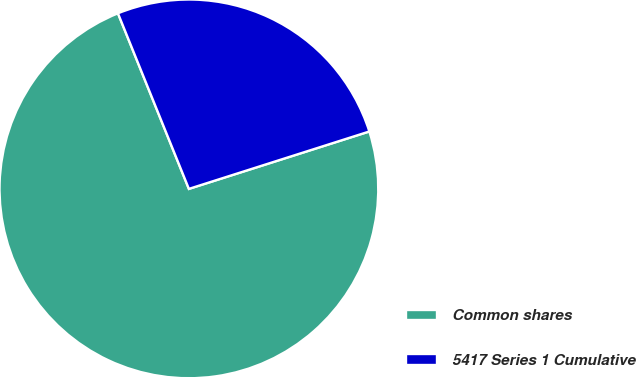<chart> <loc_0><loc_0><loc_500><loc_500><pie_chart><fcel>Common shares<fcel>5417 Series 1 Cumulative<nl><fcel>73.79%<fcel>26.21%<nl></chart> 